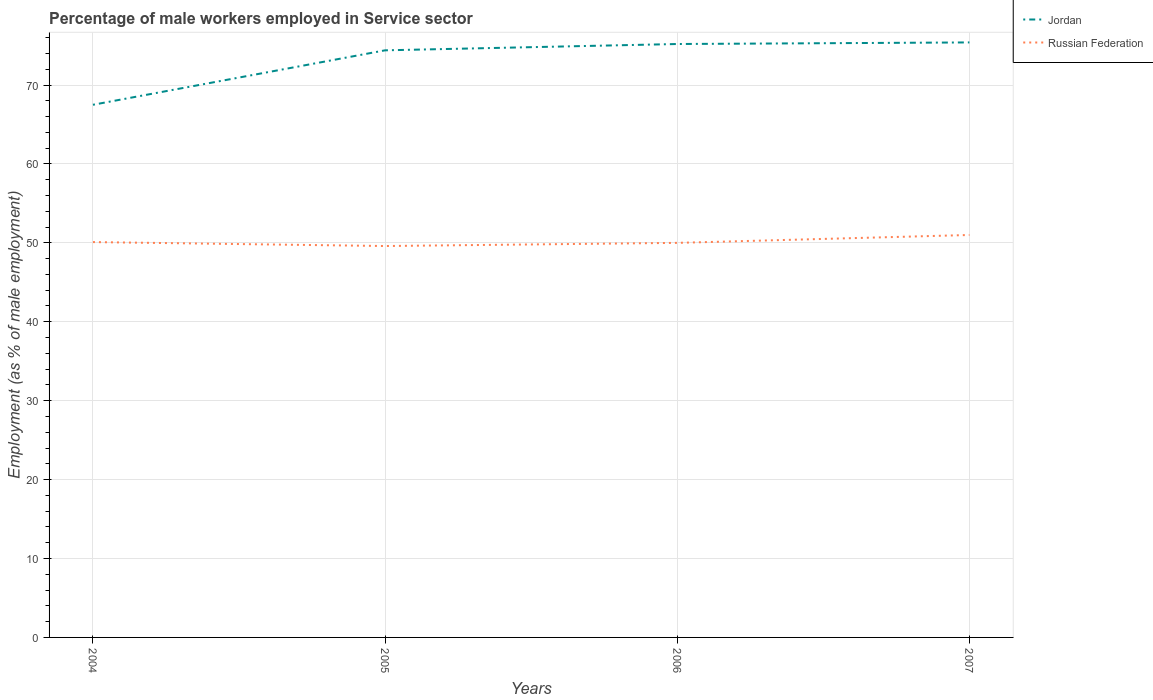Across all years, what is the maximum percentage of male workers employed in Service sector in Jordan?
Give a very brief answer. 67.5. In which year was the percentage of male workers employed in Service sector in Jordan maximum?
Give a very brief answer. 2004. What is the difference between the highest and the second highest percentage of male workers employed in Service sector in Jordan?
Ensure brevity in your answer.  7.9. What is the difference between the highest and the lowest percentage of male workers employed in Service sector in Russian Federation?
Provide a succinct answer. 1. Is the percentage of male workers employed in Service sector in Russian Federation strictly greater than the percentage of male workers employed in Service sector in Jordan over the years?
Offer a terse response. Yes. What is the difference between two consecutive major ticks on the Y-axis?
Make the answer very short. 10. Does the graph contain grids?
Provide a succinct answer. Yes. Where does the legend appear in the graph?
Provide a succinct answer. Top right. How are the legend labels stacked?
Give a very brief answer. Vertical. What is the title of the graph?
Keep it short and to the point. Percentage of male workers employed in Service sector. What is the label or title of the Y-axis?
Your response must be concise. Employment (as % of male employment). What is the Employment (as % of male employment) of Jordan in 2004?
Your response must be concise. 67.5. What is the Employment (as % of male employment) in Russian Federation in 2004?
Make the answer very short. 50.1. What is the Employment (as % of male employment) of Jordan in 2005?
Your answer should be very brief. 74.4. What is the Employment (as % of male employment) of Russian Federation in 2005?
Give a very brief answer. 49.6. What is the Employment (as % of male employment) in Jordan in 2006?
Make the answer very short. 75.2. What is the Employment (as % of male employment) of Russian Federation in 2006?
Give a very brief answer. 50. What is the Employment (as % of male employment) of Jordan in 2007?
Offer a very short reply. 75.4. Across all years, what is the maximum Employment (as % of male employment) in Jordan?
Your response must be concise. 75.4. Across all years, what is the maximum Employment (as % of male employment) of Russian Federation?
Keep it short and to the point. 51. Across all years, what is the minimum Employment (as % of male employment) of Jordan?
Provide a short and direct response. 67.5. Across all years, what is the minimum Employment (as % of male employment) of Russian Federation?
Offer a very short reply. 49.6. What is the total Employment (as % of male employment) in Jordan in the graph?
Offer a very short reply. 292.5. What is the total Employment (as % of male employment) of Russian Federation in the graph?
Keep it short and to the point. 200.7. What is the difference between the Employment (as % of male employment) of Russian Federation in 2004 and that in 2005?
Offer a terse response. 0.5. What is the difference between the Employment (as % of male employment) of Jordan in 2004 and that in 2006?
Provide a short and direct response. -7.7. What is the difference between the Employment (as % of male employment) in Russian Federation in 2004 and that in 2006?
Ensure brevity in your answer.  0.1. What is the difference between the Employment (as % of male employment) of Jordan in 2005 and that in 2006?
Offer a very short reply. -0.8. What is the difference between the Employment (as % of male employment) in Jordan in 2005 and that in 2007?
Provide a short and direct response. -1. What is the difference between the Employment (as % of male employment) of Russian Federation in 2005 and that in 2007?
Provide a succinct answer. -1.4. What is the difference between the Employment (as % of male employment) of Jordan in 2005 and the Employment (as % of male employment) of Russian Federation in 2006?
Make the answer very short. 24.4. What is the difference between the Employment (as % of male employment) in Jordan in 2005 and the Employment (as % of male employment) in Russian Federation in 2007?
Give a very brief answer. 23.4. What is the difference between the Employment (as % of male employment) of Jordan in 2006 and the Employment (as % of male employment) of Russian Federation in 2007?
Ensure brevity in your answer.  24.2. What is the average Employment (as % of male employment) in Jordan per year?
Your answer should be compact. 73.12. What is the average Employment (as % of male employment) in Russian Federation per year?
Your response must be concise. 50.17. In the year 2004, what is the difference between the Employment (as % of male employment) in Jordan and Employment (as % of male employment) in Russian Federation?
Ensure brevity in your answer.  17.4. In the year 2005, what is the difference between the Employment (as % of male employment) of Jordan and Employment (as % of male employment) of Russian Federation?
Your response must be concise. 24.8. In the year 2006, what is the difference between the Employment (as % of male employment) of Jordan and Employment (as % of male employment) of Russian Federation?
Make the answer very short. 25.2. In the year 2007, what is the difference between the Employment (as % of male employment) in Jordan and Employment (as % of male employment) in Russian Federation?
Your answer should be very brief. 24.4. What is the ratio of the Employment (as % of male employment) in Jordan in 2004 to that in 2005?
Keep it short and to the point. 0.91. What is the ratio of the Employment (as % of male employment) in Russian Federation in 2004 to that in 2005?
Your answer should be very brief. 1.01. What is the ratio of the Employment (as % of male employment) in Jordan in 2004 to that in 2006?
Provide a short and direct response. 0.9. What is the ratio of the Employment (as % of male employment) of Russian Federation in 2004 to that in 2006?
Your response must be concise. 1. What is the ratio of the Employment (as % of male employment) in Jordan in 2004 to that in 2007?
Ensure brevity in your answer.  0.9. What is the ratio of the Employment (as % of male employment) in Russian Federation in 2004 to that in 2007?
Offer a terse response. 0.98. What is the ratio of the Employment (as % of male employment) of Jordan in 2005 to that in 2006?
Your response must be concise. 0.99. What is the ratio of the Employment (as % of male employment) in Jordan in 2005 to that in 2007?
Your response must be concise. 0.99. What is the ratio of the Employment (as % of male employment) in Russian Federation in 2005 to that in 2007?
Make the answer very short. 0.97. What is the ratio of the Employment (as % of male employment) of Russian Federation in 2006 to that in 2007?
Make the answer very short. 0.98. What is the difference between the highest and the second highest Employment (as % of male employment) of Jordan?
Make the answer very short. 0.2. 